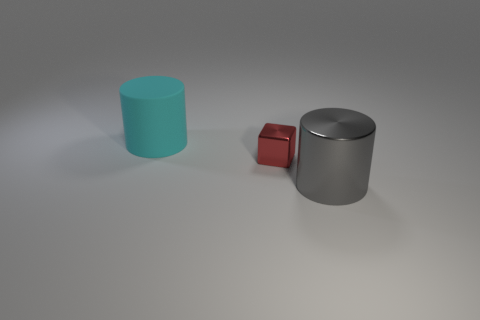Add 1 large things. How many objects exist? 4 Subtract all gray cylinders. How many cylinders are left? 1 Subtract 1 cubes. How many cubes are left? 0 Add 1 large cyan matte things. How many large cyan matte things are left? 2 Add 3 small shiny blocks. How many small shiny blocks exist? 4 Subtract 0 yellow spheres. How many objects are left? 3 Subtract all blocks. How many objects are left? 2 Subtract all brown cubes. Subtract all purple balls. How many cubes are left? 1 Subtract all red balls. How many gray cylinders are left? 1 Subtract all small cyan metallic blocks. Subtract all gray metal objects. How many objects are left? 2 